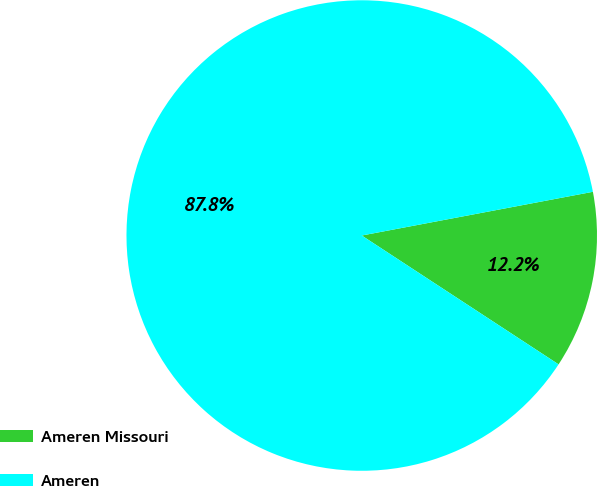Convert chart. <chart><loc_0><loc_0><loc_500><loc_500><pie_chart><fcel>Ameren Missouri<fcel>Ameren<nl><fcel>12.2%<fcel>87.8%<nl></chart> 